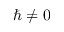Convert formula to latex. <formula><loc_0><loc_0><loc_500><loc_500>\hbar { \neq } 0</formula> 